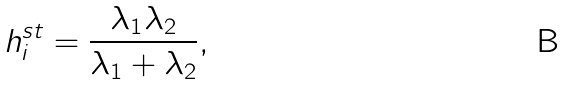<formula> <loc_0><loc_0><loc_500><loc_500>h _ { i } ^ { s t } = \frac { \lambda _ { 1 } \lambda _ { 2 } } { \lambda _ { 1 } + \lambda _ { 2 } } ,</formula> 